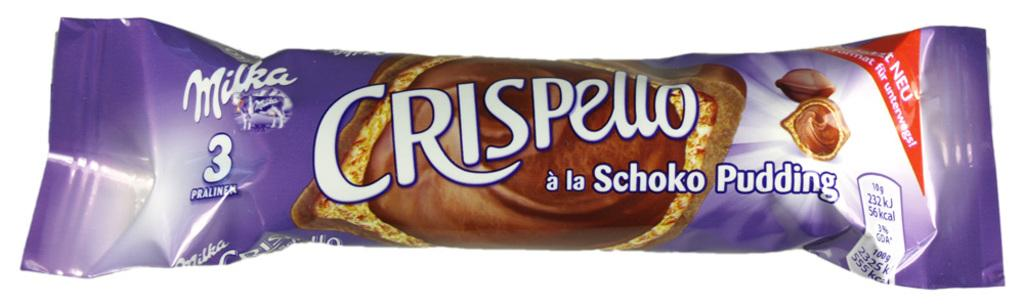What is present in the image that is related to chocolate? There is a chocolate wrapper in the image. Can you describe the chocolate wrapper in more detail? Yes, there is text on the chocolate wrapper. What color is the paste used to create the text on the chocolate wrapper? There is no mention of paste or its color in the image or the provided facts. 